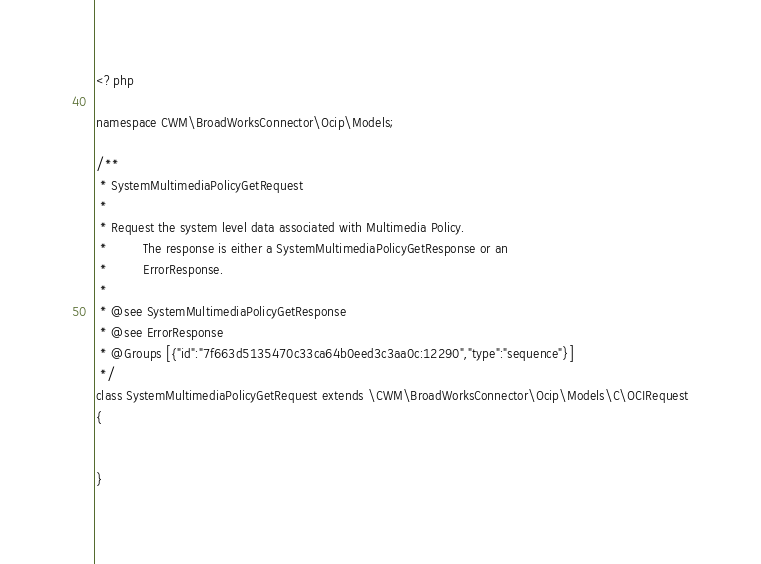Convert code to text. <code><loc_0><loc_0><loc_500><loc_500><_PHP_><?php

namespace CWM\BroadWorksConnector\Ocip\Models;

/**
 * SystemMultimediaPolicyGetRequest
 *
 * Request the system level data associated with Multimedia Policy.
 *         The response is either a SystemMultimediaPolicyGetResponse or an
 *         ErrorResponse.
 *
 * @see SystemMultimediaPolicyGetResponse
 * @see ErrorResponse
 * @Groups [{"id":"7f663d5135470c33ca64b0eed3c3aa0c:12290","type":"sequence"}]
 */
class SystemMultimediaPolicyGetRequest extends \CWM\BroadWorksConnector\Ocip\Models\C\OCIRequest
{


}

</code> 